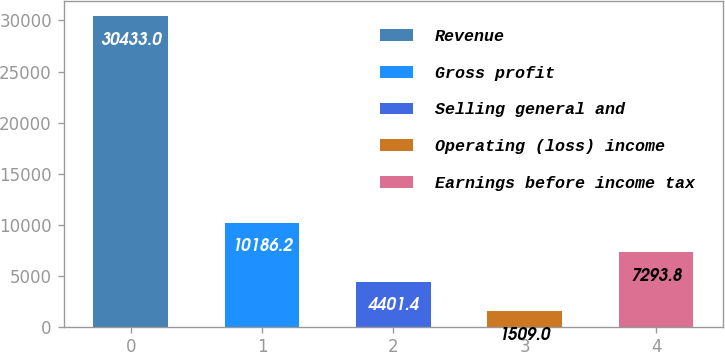Convert chart to OTSL. <chart><loc_0><loc_0><loc_500><loc_500><bar_chart><fcel>Revenue<fcel>Gross profit<fcel>Selling general and<fcel>Operating (loss) income<fcel>Earnings before income tax<nl><fcel>30433<fcel>10186.2<fcel>4401.4<fcel>1509<fcel>7293.8<nl></chart> 